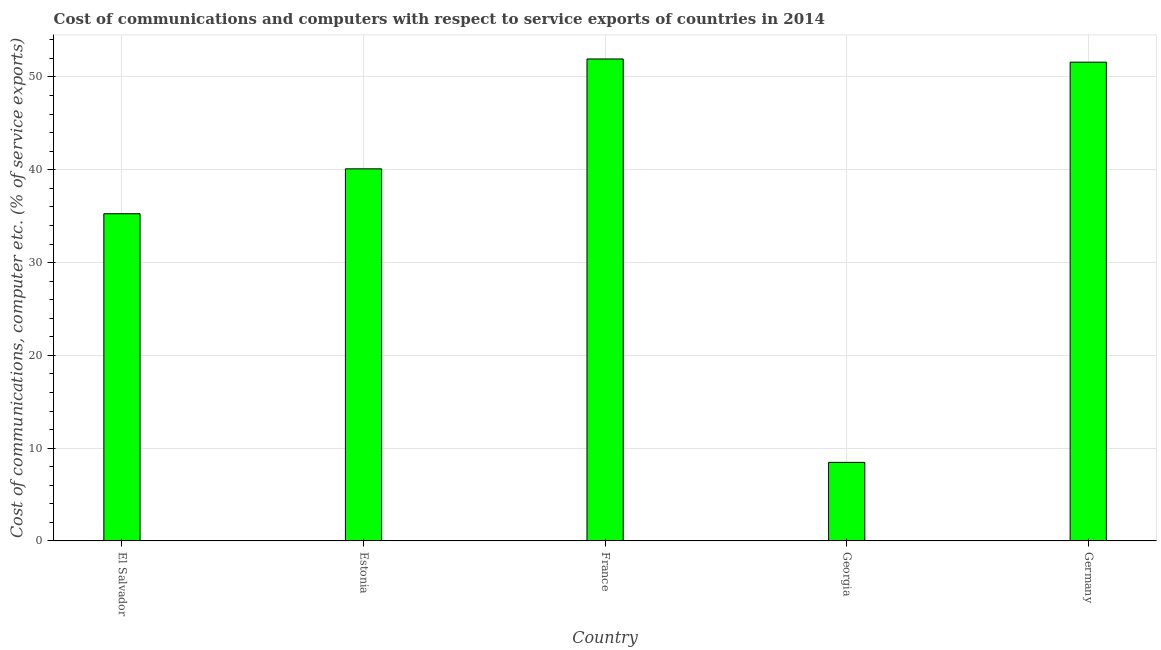Does the graph contain grids?
Your response must be concise. Yes. What is the title of the graph?
Your response must be concise. Cost of communications and computers with respect to service exports of countries in 2014. What is the label or title of the Y-axis?
Offer a terse response. Cost of communications, computer etc. (% of service exports). What is the cost of communications and computer in Georgia?
Your answer should be compact. 8.47. Across all countries, what is the maximum cost of communications and computer?
Offer a terse response. 51.94. Across all countries, what is the minimum cost of communications and computer?
Ensure brevity in your answer.  8.47. In which country was the cost of communications and computer minimum?
Your response must be concise. Georgia. What is the sum of the cost of communications and computer?
Make the answer very short. 187.37. What is the difference between the cost of communications and computer in France and Germany?
Provide a short and direct response. 0.34. What is the average cost of communications and computer per country?
Your answer should be compact. 37.48. What is the median cost of communications and computer?
Offer a very short reply. 40.1. In how many countries, is the cost of communications and computer greater than 40 %?
Offer a very short reply. 3. What is the ratio of the cost of communications and computer in Estonia to that in France?
Offer a terse response. 0.77. What is the difference between the highest and the second highest cost of communications and computer?
Provide a succinct answer. 0.34. Is the sum of the cost of communications and computer in El Salvador and Germany greater than the maximum cost of communications and computer across all countries?
Your answer should be compact. Yes. What is the difference between the highest and the lowest cost of communications and computer?
Ensure brevity in your answer.  43.47. How many countries are there in the graph?
Your answer should be compact. 5. What is the difference between two consecutive major ticks on the Y-axis?
Make the answer very short. 10. What is the Cost of communications, computer etc. (% of service exports) in El Salvador?
Give a very brief answer. 35.26. What is the Cost of communications, computer etc. (% of service exports) of Estonia?
Your answer should be compact. 40.1. What is the Cost of communications, computer etc. (% of service exports) of France?
Your response must be concise. 51.94. What is the Cost of communications, computer etc. (% of service exports) in Georgia?
Keep it short and to the point. 8.47. What is the Cost of communications, computer etc. (% of service exports) in Germany?
Ensure brevity in your answer.  51.6. What is the difference between the Cost of communications, computer etc. (% of service exports) in El Salvador and Estonia?
Your response must be concise. -4.84. What is the difference between the Cost of communications, computer etc. (% of service exports) in El Salvador and France?
Ensure brevity in your answer.  -16.68. What is the difference between the Cost of communications, computer etc. (% of service exports) in El Salvador and Georgia?
Offer a very short reply. 26.79. What is the difference between the Cost of communications, computer etc. (% of service exports) in El Salvador and Germany?
Give a very brief answer. -16.33. What is the difference between the Cost of communications, computer etc. (% of service exports) in Estonia and France?
Your answer should be very brief. -11.84. What is the difference between the Cost of communications, computer etc. (% of service exports) in Estonia and Georgia?
Your response must be concise. 31.63. What is the difference between the Cost of communications, computer etc. (% of service exports) in Estonia and Germany?
Offer a terse response. -11.5. What is the difference between the Cost of communications, computer etc. (% of service exports) in France and Georgia?
Make the answer very short. 43.47. What is the difference between the Cost of communications, computer etc. (% of service exports) in France and Germany?
Offer a very short reply. 0.34. What is the difference between the Cost of communications, computer etc. (% of service exports) in Georgia and Germany?
Offer a very short reply. -43.13. What is the ratio of the Cost of communications, computer etc. (% of service exports) in El Salvador to that in Estonia?
Make the answer very short. 0.88. What is the ratio of the Cost of communications, computer etc. (% of service exports) in El Salvador to that in France?
Offer a very short reply. 0.68. What is the ratio of the Cost of communications, computer etc. (% of service exports) in El Salvador to that in Georgia?
Provide a succinct answer. 4.16. What is the ratio of the Cost of communications, computer etc. (% of service exports) in El Salvador to that in Germany?
Your response must be concise. 0.68. What is the ratio of the Cost of communications, computer etc. (% of service exports) in Estonia to that in France?
Provide a succinct answer. 0.77. What is the ratio of the Cost of communications, computer etc. (% of service exports) in Estonia to that in Georgia?
Provide a short and direct response. 4.73. What is the ratio of the Cost of communications, computer etc. (% of service exports) in Estonia to that in Germany?
Keep it short and to the point. 0.78. What is the ratio of the Cost of communications, computer etc. (% of service exports) in France to that in Georgia?
Offer a terse response. 6.13. What is the ratio of the Cost of communications, computer etc. (% of service exports) in France to that in Germany?
Offer a very short reply. 1.01. What is the ratio of the Cost of communications, computer etc. (% of service exports) in Georgia to that in Germany?
Provide a short and direct response. 0.16. 